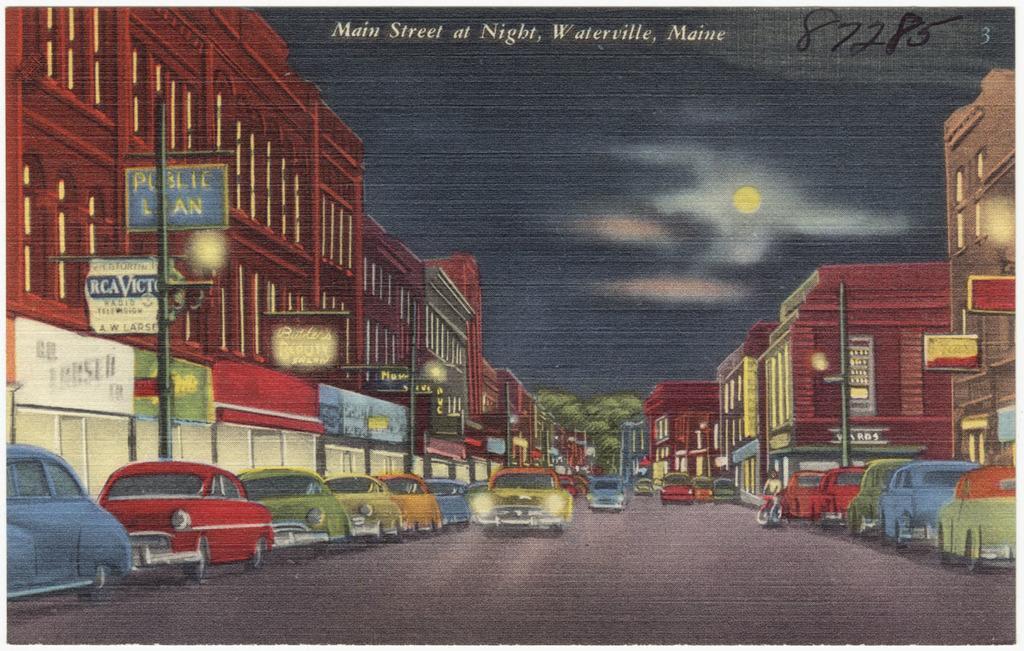In one or two sentences, can you explain what this image depicts? In this image I can see it is an animated picture and there is a text written on it. And there are cars on the road. And there is a person holding motorcycle. And there are buildings and poles. And there are boards attached to the pole. And at the top there is a moon and a sky. 